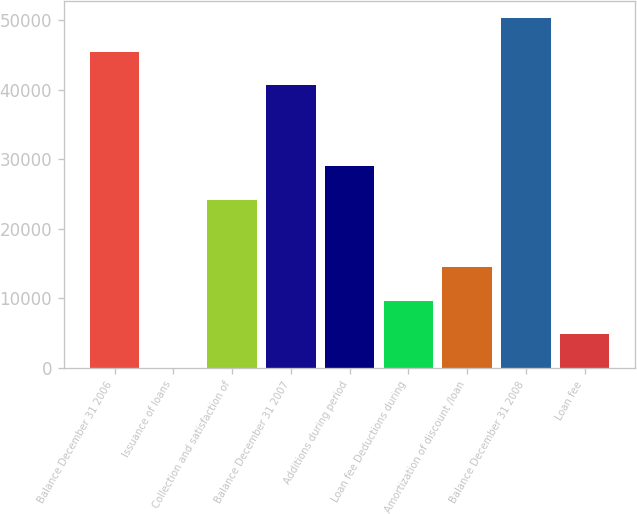<chart> <loc_0><loc_0><loc_500><loc_500><bar_chart><fcel>Balance December 31 2006<fcel>Issuance of loans<fcel>Collection and satisfaction of<fcel>Balance December 31 2007<fcel>Additions during period<fcel>Loan fee Deductions during<fcel>Amortization of discount /loan<fcel>Balance December 31 2008<fcel>Loan fee<nl><fcel>45470.8<fcel>8<fcel>24172<fcel>40638<fcel>29004.8<fcel>9673.6<fcel>14506.4<fcel>50303.6<fcel>4840.8<nl></chart> 